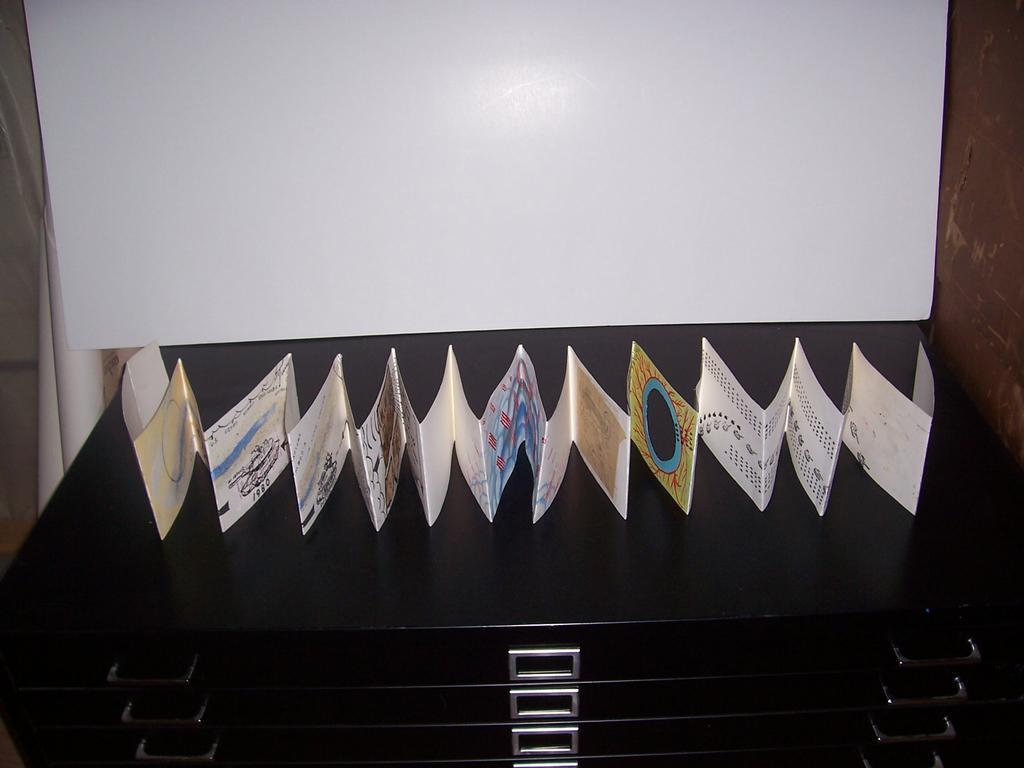Describe this image in one or two sentences. In this image, I can see a paper craft on a desk with drawers. In the background, I can see a white board. On the right side of the image, it looks like a wall. On the left side of the image, there are few objects. 